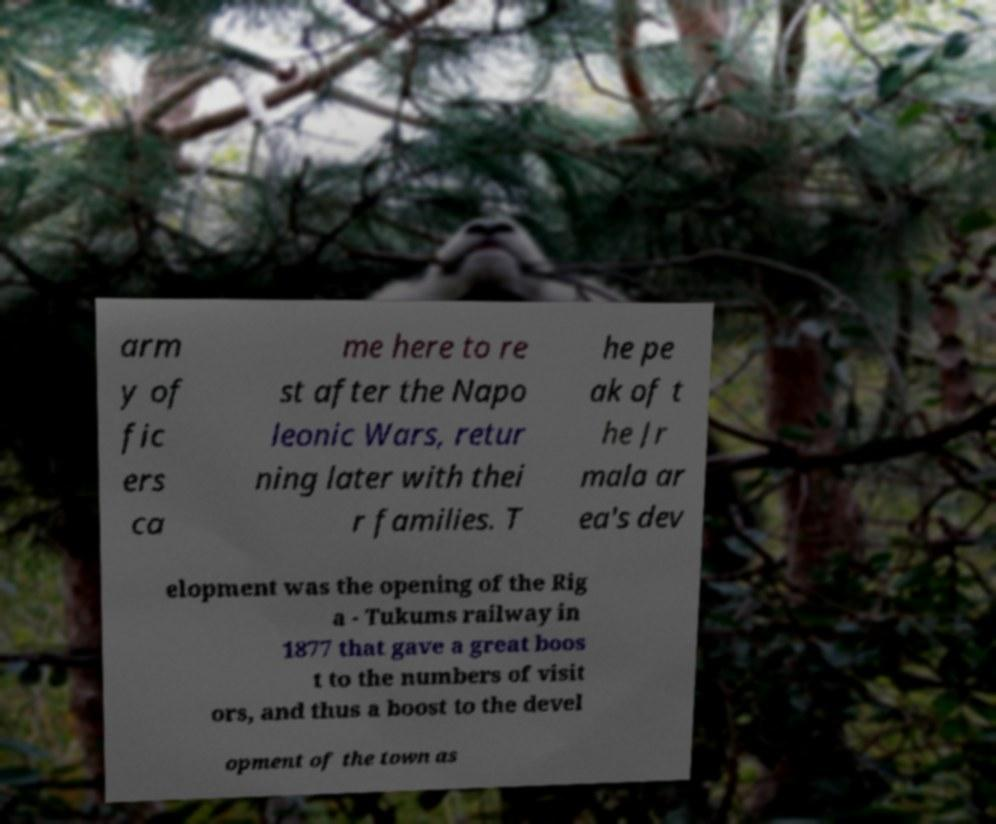There's text embedded in this image that I need extracted. Can you transcribe it verbatim? arm y of fic ers ca me here to re st after the Napo leonic Wars, retur ning later with thei r families. T he pe ak of t he Jr mala ar ea's dev elopment was the opening of the Rig a - Tukums railway in 1877 that gave a great boos t to the numbers of visit ors, and thus a boost to the devel opment of the town as 